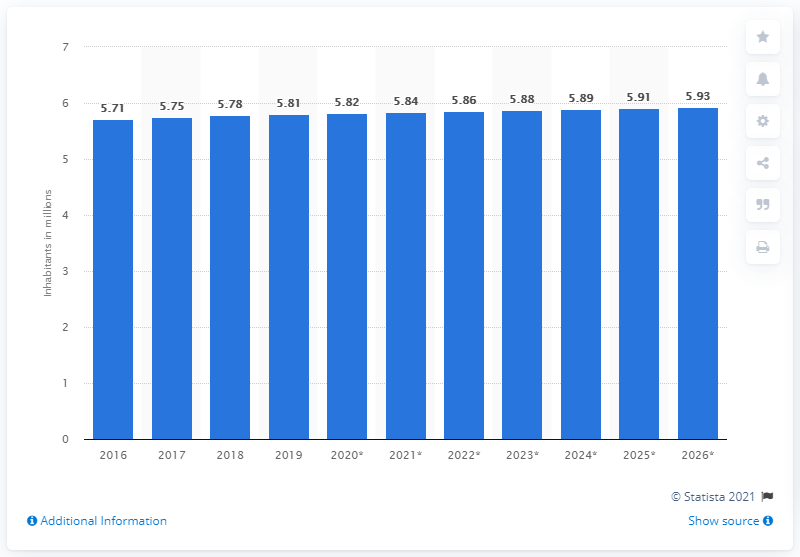Outline some significant characteristics in this image. In 2019, the population of Denmark was approximately 5.86 million people. 